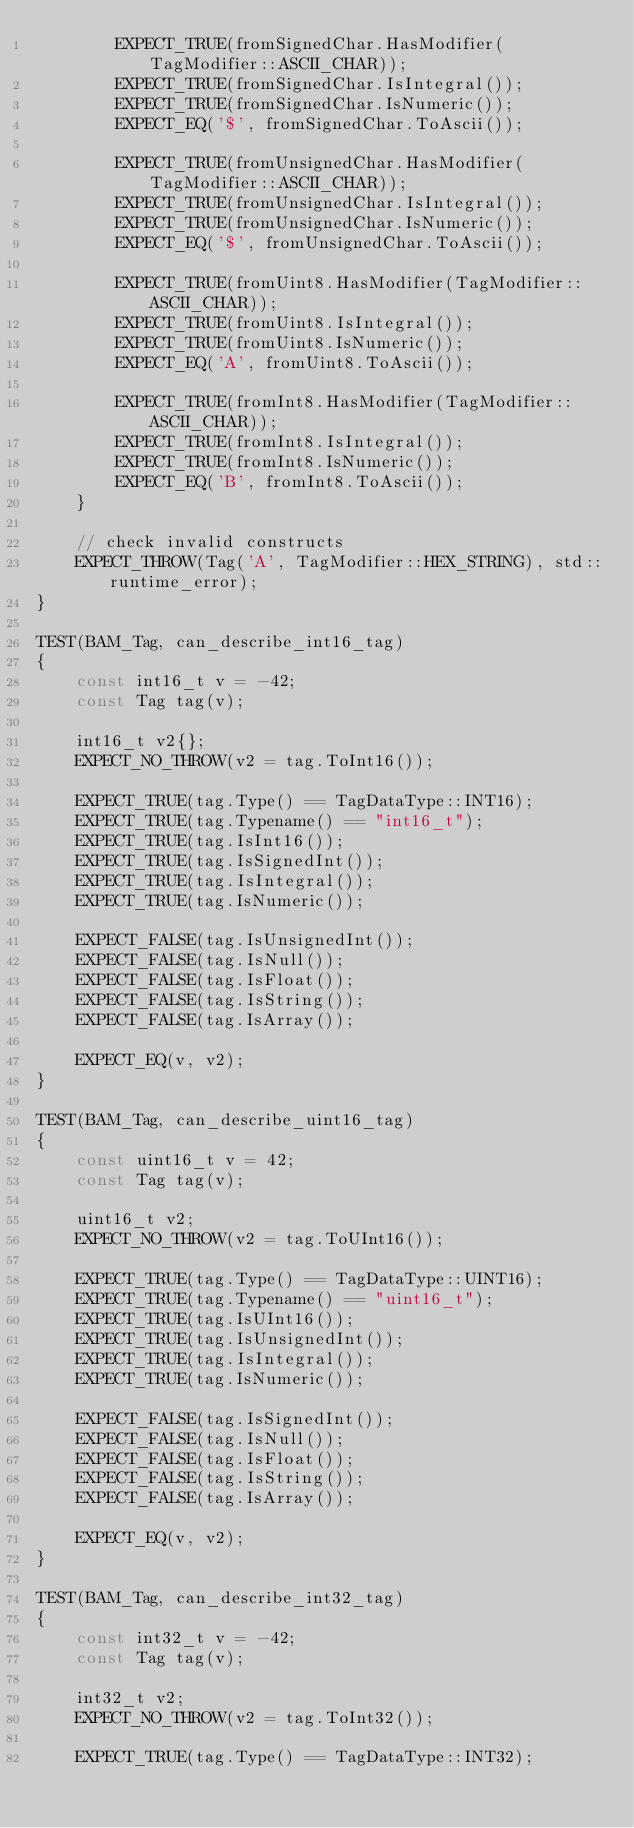<code> <loc_0><loc_0><loc_500><loc_500><_C++_>        EXPECT_TRUE(fromSignedChar.HasModifier(TagModifier::ASCII_CHAR));
        EXPECT_TRUE(fromSignedChar.IsIntegral());
        EXPECT_TRUE(fromSignedChar.IsNumeric());
        EXPECT_EQ('$', fromSignedChar.ToAscii());

        EXPECT_TRUE(fromUnsignedChar.HasModifier(TagModifier::ASCII_CHAR));
        EXPECT_TRUE(fromUnsignedChar.IsIntegral());
        EXPECT_TRUE(fromUnsignedChar.IsNumeric());
        EXPECT_EQ('$', fromUnsignedChar.ToAscii());

        EXPECT_TRUE(fromUint8.HasModifier(TagModifier::ASCII_CHAR));
        EXPECT_TRUE(fromUint8.IsIntegral());
        EXPECT_TRUE(fromUint8.IsNumeric());
        EXPECT_EQ('A', fromUint8.ToAscii());

        EXPECT_TRUE(fromInt8.HasModifier(TagModifier::ASCII_CHAR));
        EXPECT_TRUE(fromInt8.IsIntegral());
        EXPECT_TRUE(fromInt8.IsNumeric());
        EXPECT_EQ('B', fromInt8.ToAscii());
    }

    // check invalid constructs
    EXPECT_THROW(Tag('A', TagModifier::HEX_STRING), std::runtime_error);
}

TEST(BAM_Tag, can_describe_int16_tag)
{
    const int16_t v = -42;
    const Tag tag(v);

    int16_t v2{};
    EXPECT_NO_THROW(v2 = tag.ToInt16());

    EXPECT_TRUE(tag.Type() == TagDataType::INT16);
    EXPECT_TRUE(tag.Typename() == "int16_t");
    EXPECT_TRUE(tag.IsInt16());
    EXPECT_TRUE(tag.IsSignedInt());
    EXPECT_TRUE(tag.IsIntegral());
    EXPECT_TRUE(tag.IsNumeric());

    EXPECT_FALSE(tag.IsUnsignedInt());
    EXPECT_FALSE(tag.IsNull());
    EXPECT_FALSE(tag.IsFloat());
    EXPECT_FALSE(tag.IsString());
    EXPECT_FALSE(tag.IsArray());

    EXPECT_EQ(v, v2);
}

TEST(BAM_Tag, can_describe_uint16_tag)
{
    const uint16_t v = 42;
    const Tag tag(v);

    uint16_t v2;
    EXPECT_NO_THROW(v2 = tag.ToUInt16());

    EXPECT_TRUE(tag.Type() == TagDataType::UINT16);
    EXPECT_TRUE(tag.Typename() == "uint16_t");
    EXPECT_TRUE(tag.IsUInt16());
    EXPECT_TRUE(tag.IsUnsignedInt());
    EXPECT_TRUE(tag.IsIntegral());
    EXPECT_TRUE(tag.IsNumeric());

    EXPECT_FALSE(tag.IsSignedInt());
    EXPECT_FALSE(tag.IsNull());
    EXPECT_FALSE(tag.IsFloat());
    EXPECT_FALSE(tag.IsString());
    EXPECT_FALSE(tag.IsArray());

    EXPECT_EQ(v, v2);
}

TEST(BAM_Tag, can_describe_int32_tag)
{
    const int32_t v = -42;
    const Tag tag(v);

    int32_t v2;
    EXPECT_NO_THROW(v2 = tag.ToInt32());

    EXPECT_TRUE(tag.Type() == TagDataType::INT32);</code> 